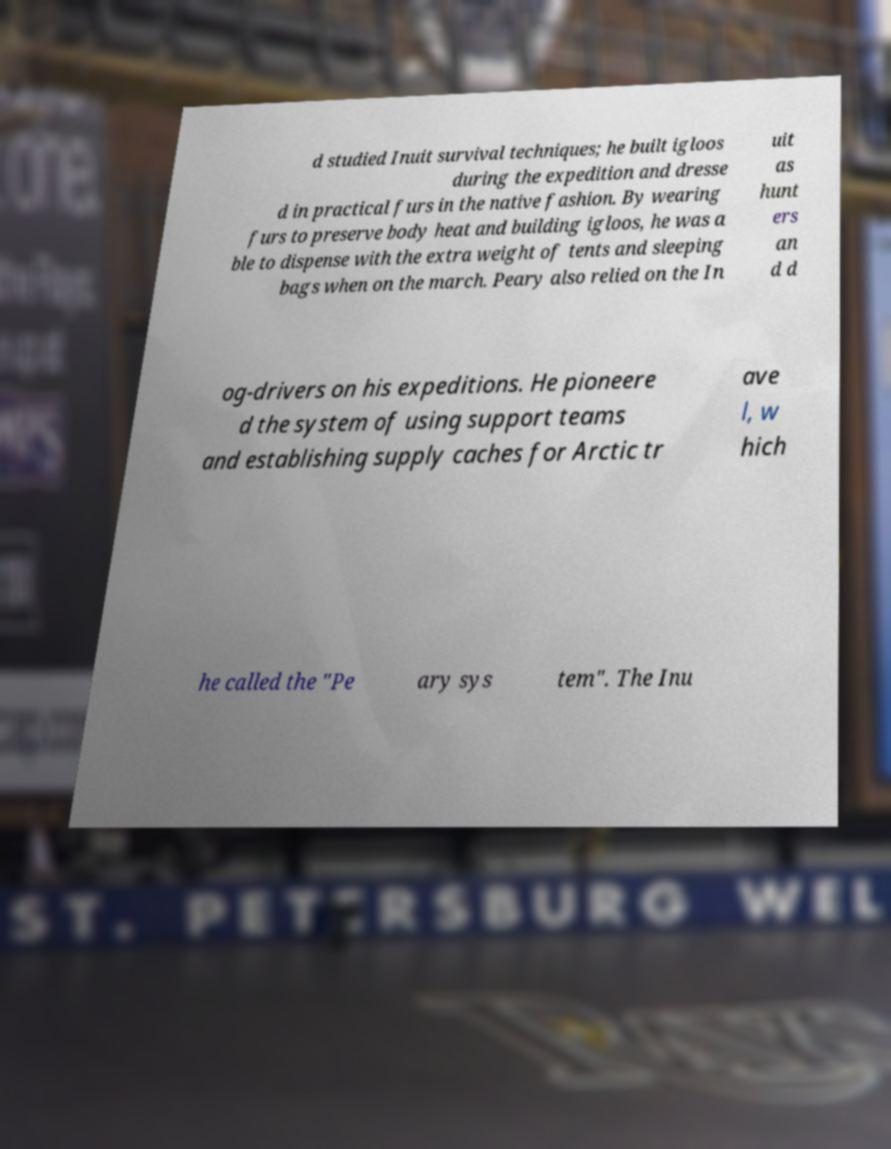For documentation purposes, I need the text within this image transcribed. Could you provide that? d studied Inuit survival techniques; he built igloos during the expedition and dresse d in practical furs in the native fashion. By wearing furs to preserve body heat and building igloos, he was a ble to dispense with the extra weight of tents and sleeping bags when on the march. Peary also relied on the In uit as hunt ers an d d og-drivers on his expeditions. He pioneere d the system of using support teams and establishing supply caches for Arctic tr ave l, w hich he called the "Pe ary sys tem". The Inu 